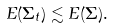Convert formula to latex. <formula><loc_0><loc_0><loc_500><loc_500>E ( \Sigma _ { t } ) \lesssim E ( \Sigma ) .</formula> 